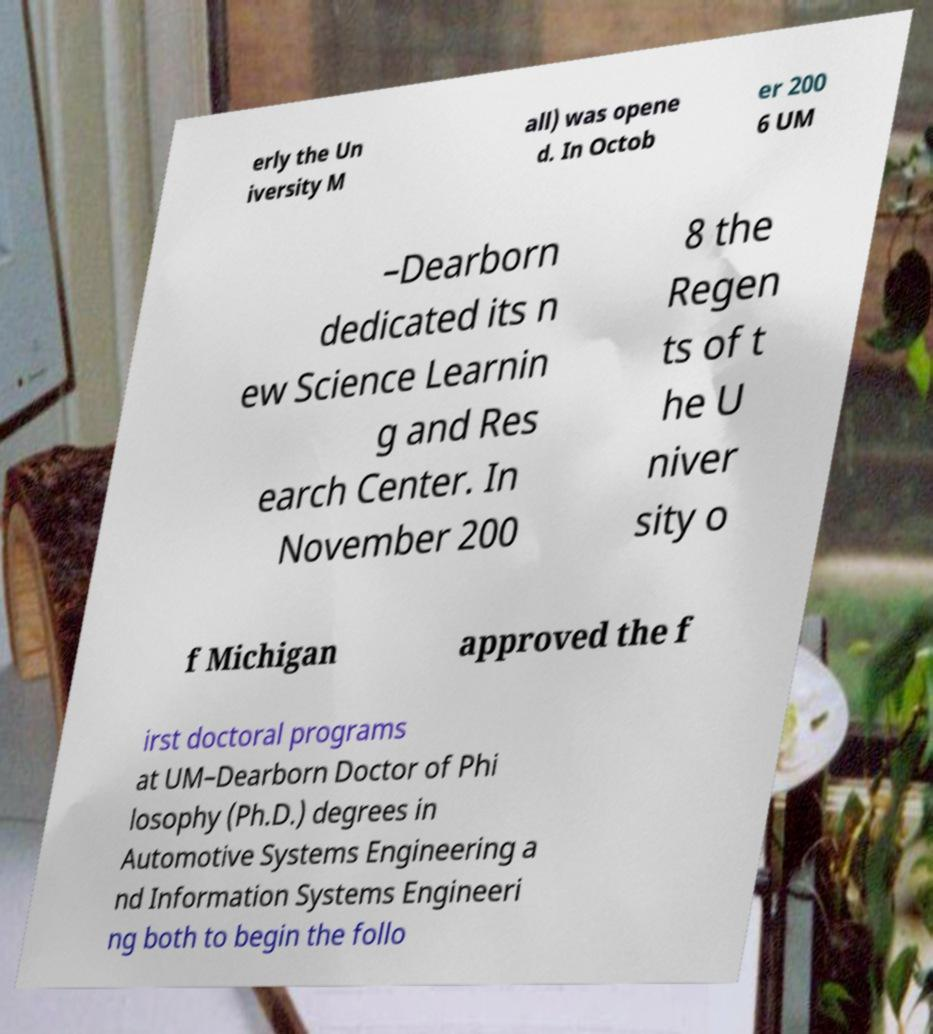What messages or text are displayed in this image? I need them in a readable, typed format. erly the Un iversity M all) was opene d. In Octob er 200 6 UM –Dearborn dedicated its n ew Science Learnin g and Res earch Center. In November 200 8 the Regen ts of t he U niver sity o f Michigan approved the f irst doctoral programs at UM–Dearborn Doctor of Phi losophy (Ph.D.) degrees in Automotive Systems Engineering a nd Information Systems Engineeri ng both to begin the follo 